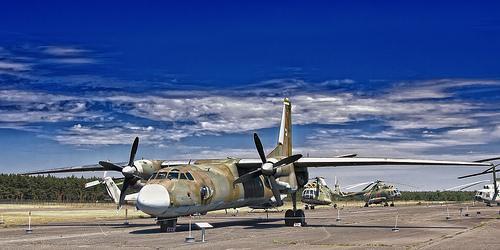How many planes are there?
Give a very brief answer. 1. How many turbines are there?
Give a very brief answer. 2. 